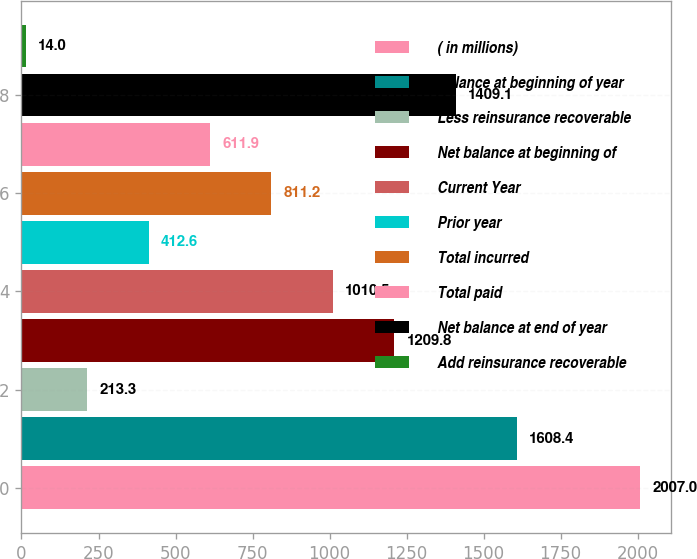<chart> <loc_0><loc_0><loc_500><loc_500><bar_chart><fcel>( in millions)<fcel>Balance at beginning of year<fcel>Less reinsurance recoverable<fcel>Net balance at beginning of<fcel>Current Year<fcel>Prior year<fcel>Total incurred<fcel>Total paid<fcel>Net balance at end of year<fcel>Add reinsurance recoverable<nl><fcel>2007<fcel>1608.4<fcel>213.3<fcel>1209.8<fcel>1010.5<fcel>412.6<fcel>811.2<fcel>611.9<fcel>1409.1<fcel>14<nl></chart> 